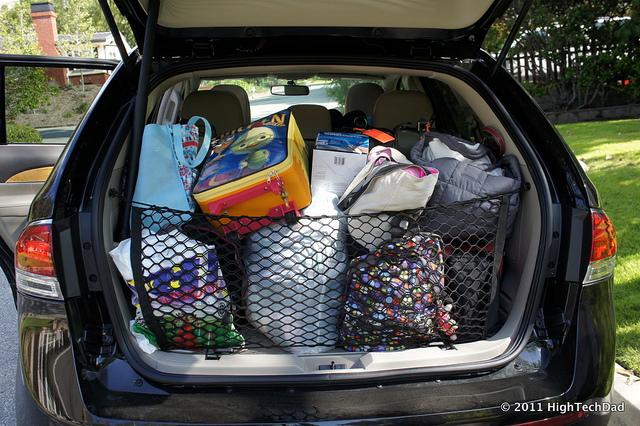Is the back of the car empty?
Keep it brief. No. What type of vehicle is this?
Quick response, please. Station wagon. What color is the nearest storage bin?
Concise answer only. White. What color is the cardboard box?
Quick response, please. Blue. What is placed in the boot of the car?
Be succinct. Luggage. What is packed in the back of this car?
Concise answer only. Luggage. 